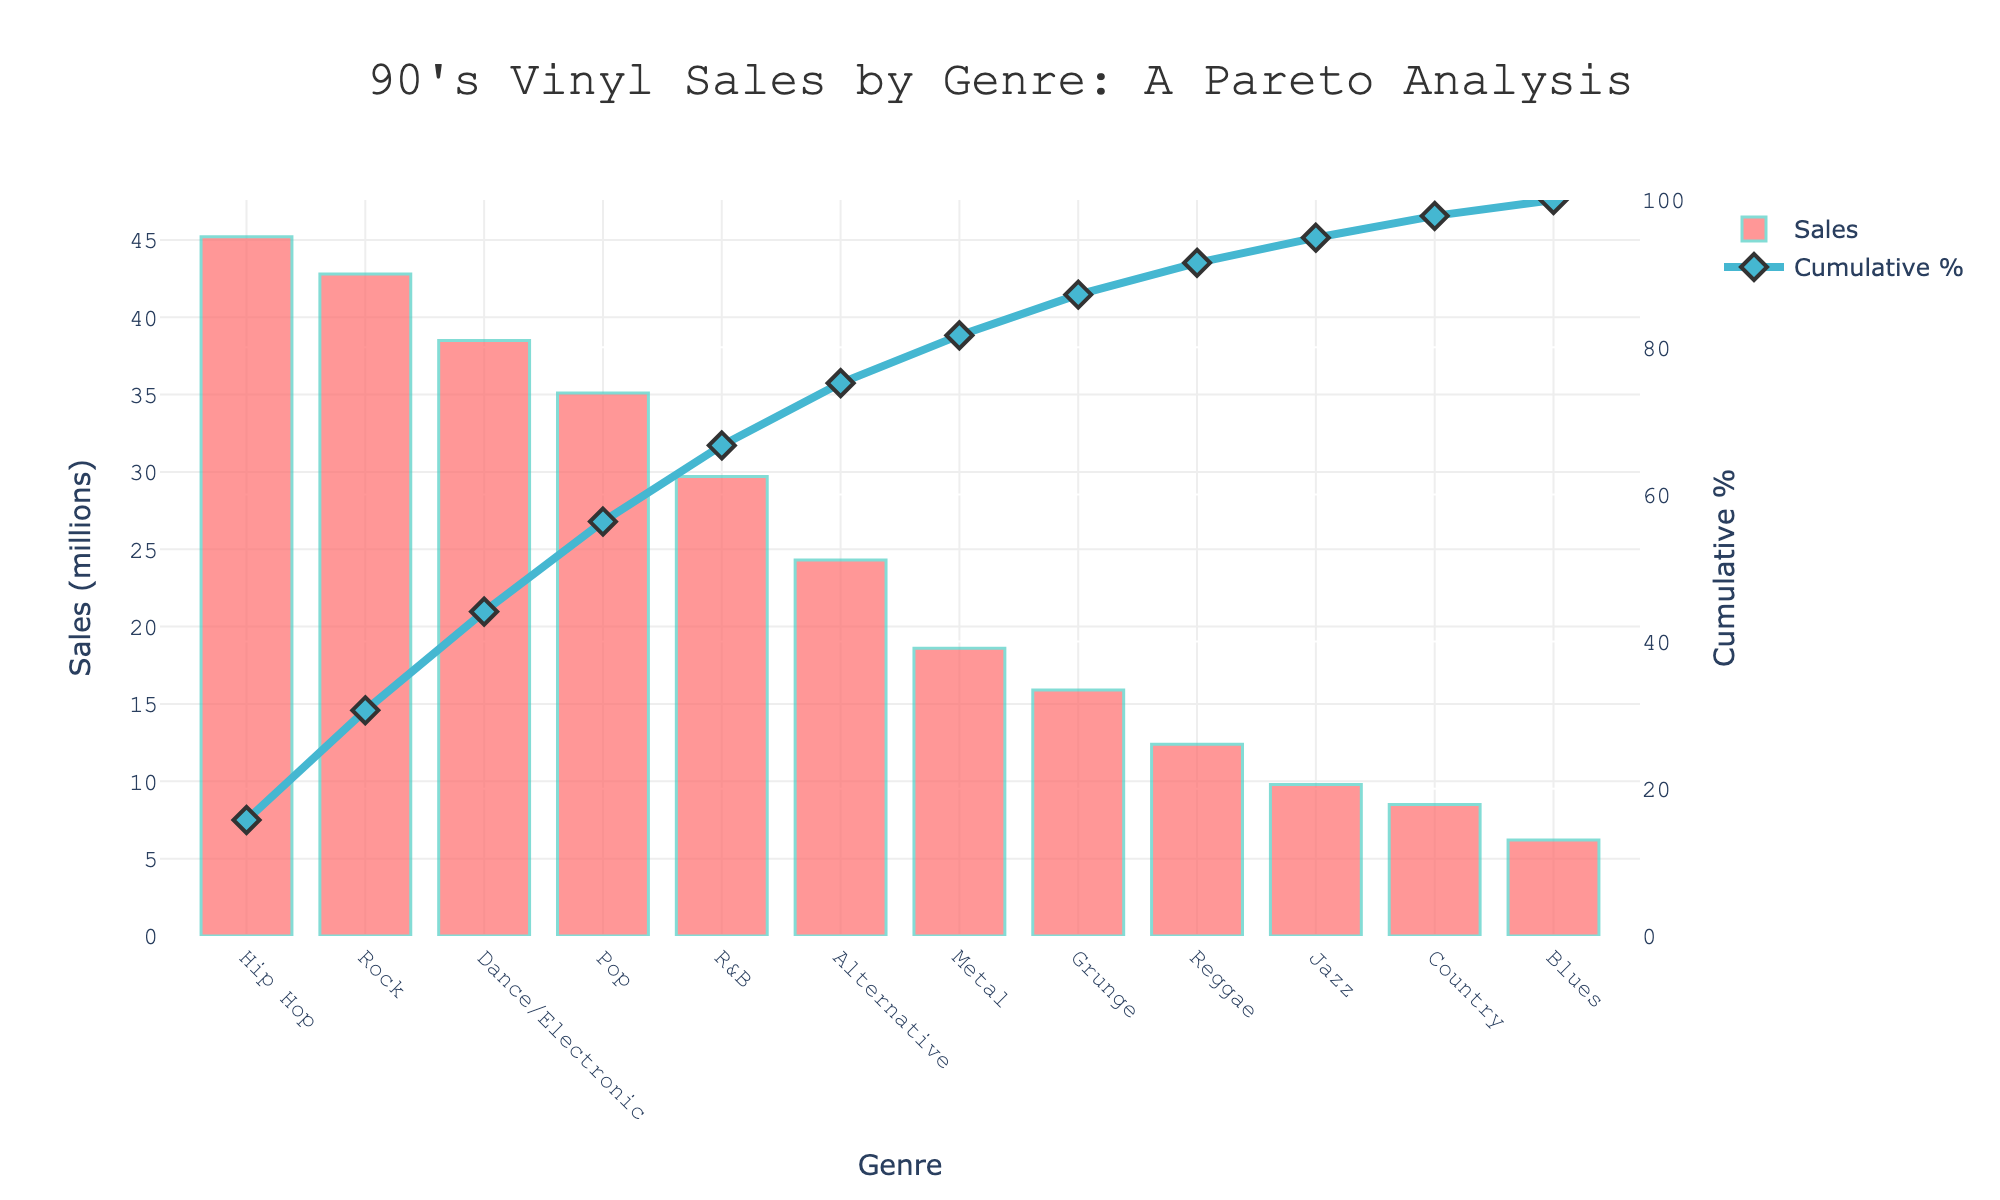What is the title of the figure? The title is prominently displayed at the top of the figure. It reads "90's Vinyl Sales by Genre: A Pareto Analysis".
Answer: 90's Vinyl Sales by Genre: A Pareto Analysis Which genre has the highest vinyl sales according to the figure? The bars represent sales by genre, and the tallest bar is for Hip Hop.
Answer: Hip Hop How many genres have sales above 30 million? By counting the bars that extend above the 30 million sales mark, we can see there are 4 genres (Hip Hop, Rock, Dance/Electronic, Pop).
Answer: 4 What is the total sales of the top 3 genres combined? The top 3 genres are Hip Hop (45.2 million), Rock (42.8 million), and Dance/Electronic (38.5 million). Their combined sales are 45.2 + 42.8 + 38.5.
Answer: 126.5 million What is the cumulative percentage of sales reached by the top 2 genres? The figure shows that the cumulative percentage is marked by the diamond symbols for each genre. At the second diamond marker, which includes Hip Hop and Rock, the cumulative percentage is around 42%.
Answer: 42% Which genre has the lowest vinyl sales? The shortest bar corresponds to Blues.
Answer: Blues Compare the sales of Pop and Jazz. How much more is Pop? Pop has 35.1 million sales and Jazz has 9.8 million sales. The difference is 35.1 - 9.8.
Answer: 25.3 million What percentage of total sales does the top genre, Hip Hop, represent? Hip Hop sales are 45.2 million. The cumulative percentage for Hip Hop is at the first diamond marker, indicating it's approximately 19%.
Answer: 19% Between Alternative and Country, which genre sold more vinyl records? The bar for Alternative is higher than the bar for Country.
Answer: Alternative How many genres make up the first 80% of the cumulative sales? By following the cumulative percentage line (diamonds) to the 80% mark, it is reached between the genres of R&B and Alternative, indicating 5 genres (Hip Hop, Rock, Dance/Electronic, Pop, R&B).
Answer: 5 